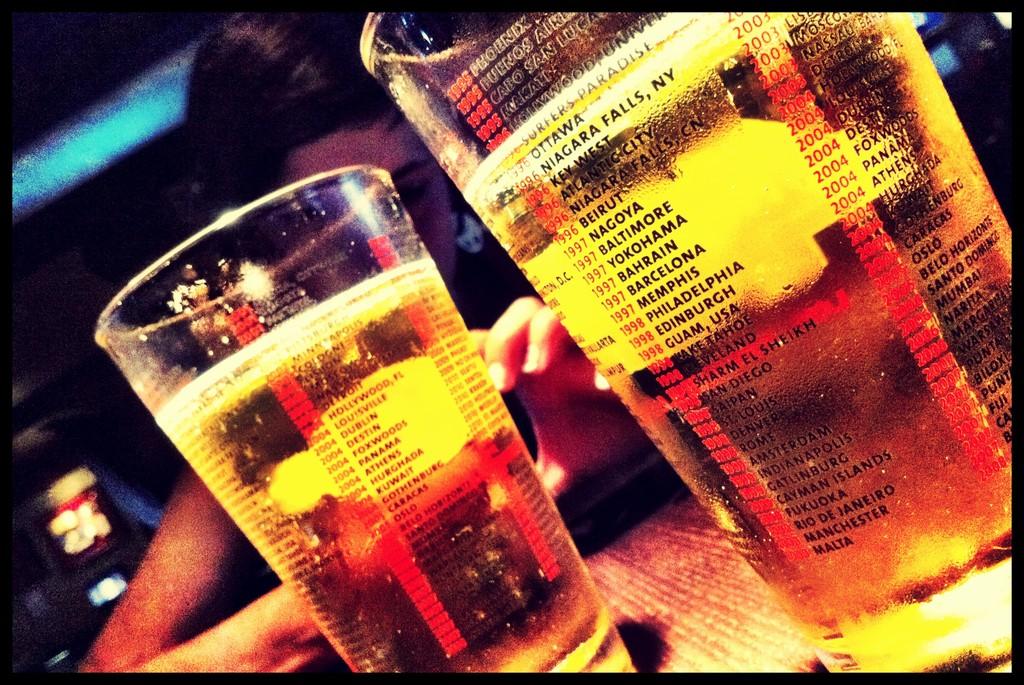What is one of the city names on the beer cup?
Give a very brief answer. Baltimore. What is the ny city on the right glass?
Offer a terse response. Niagara falls. 